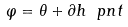<formula> <loc_0><loc_0><loc_500><loc_500>\varphi = \theta + \partial h \ p n t</formula> 